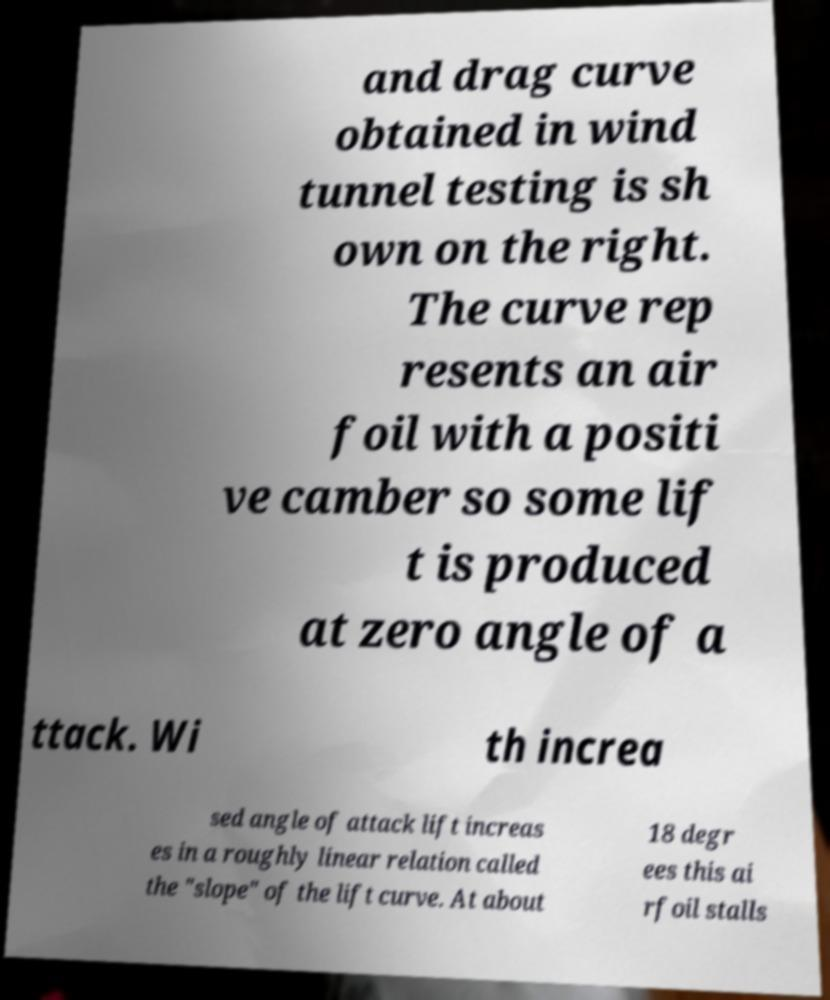Please read and relay the text visible in this image. What does it say? and drag curve obtained in wind tunnel testing is sh own on the right. The curve rep resents an air foil with a positi ve camber so some lif t is produced at zero angle of a ttack. Wi th increa sed angle of attack lift increas es in a roughly linear relation called the "slope" of the lift curve. At about 18 degr ees this ai rfoil stalls 